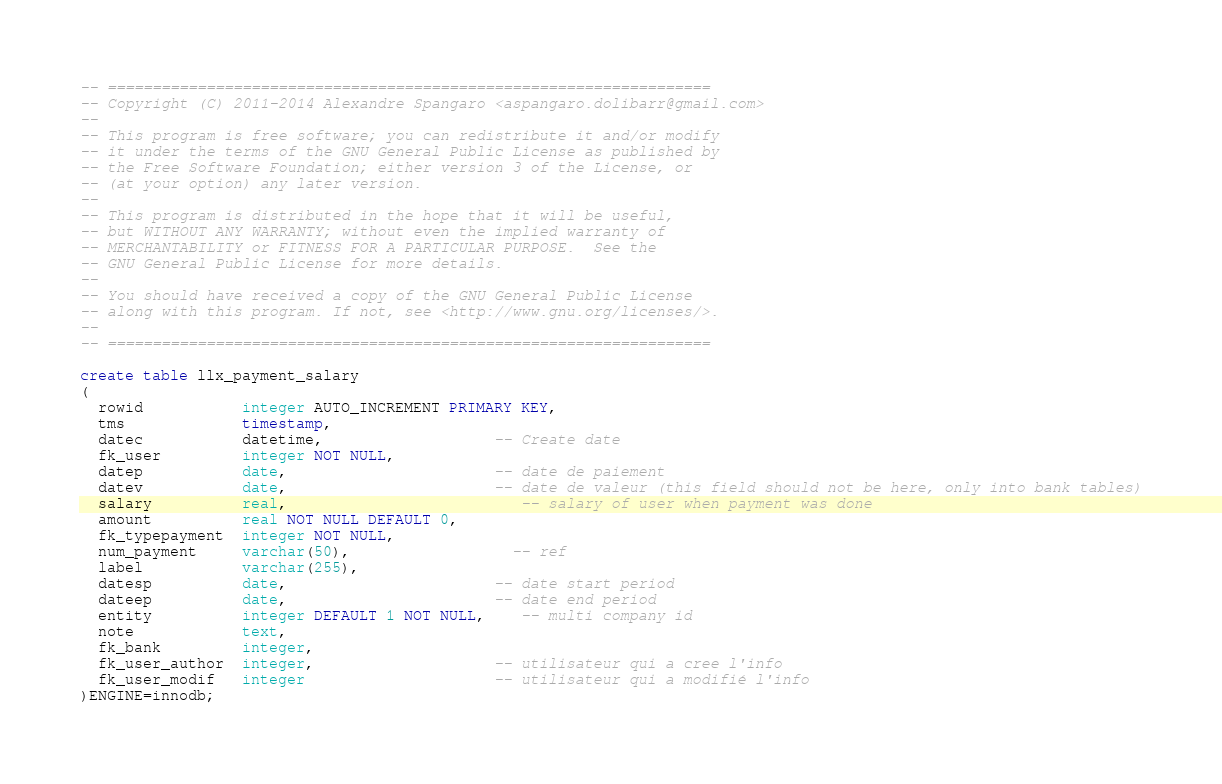<code> <loc_0><loc_0><loc_500><loc_500><_SQL_>-- ===================================================================
-- Copyright (C) 2011-2014 Alexandre Spangaro <aspangaro.dolibarr@gmail.com>
--
-- This program is free software; you can redistribute it and/or modify
-- it under the terms of the GNU General Public License as published by
-- the Free Software Foundation; either version 3 of the License, or
-- (at your option) any later version.
--
-- This program is distributed in the hope that it will be useful,
-- but WITHOUT ANY WARRANTY; without even the implied warranty of
-- MERCHANTABILITY or FITNESS FOR A PARTICULAR PURPOSE.  See the
-- GNU General Public License for more details.
--
-- You should have received a copy of the GNU General Public License
-- along with this program. If not, see <http://www.gnu.org/licenses/>.
--
-- ===================================================================

create table llx_payment_salary
(
  rowid           integer AUTO_INCREMENT PRIMARY KEY,
  tms             timestamp,
  datec           datetime,                   -- Create date
  fk_user         integer NOT NULL,
  datep           date,                       -- date de paiement
  datev           date,                       -- date de valeur (this field should not be here, only into bank tables)
  salary          real,						  -- salary of user when payment was done
  amount          real NOT NULL DEFAULT 0,
  fk_typepayment  integer NOT NULL,
  num_payment     varchar(50),				  -- ref
  label           varchar(255),
  datesp          date,                       -- date start period
  dateep          date,                       -- date end period    
  entity          integer DEFAULT 1 NOT NULL,	-- multi company id
  note            text,
  fk_bank         integer,  
  fk_user_author  integer,                    -- utilisateur qui a cree l'info
  fk_user_modif   integer                     -- utilisateur qui a modifié l'info
)ENGINE=innodb;</code> 